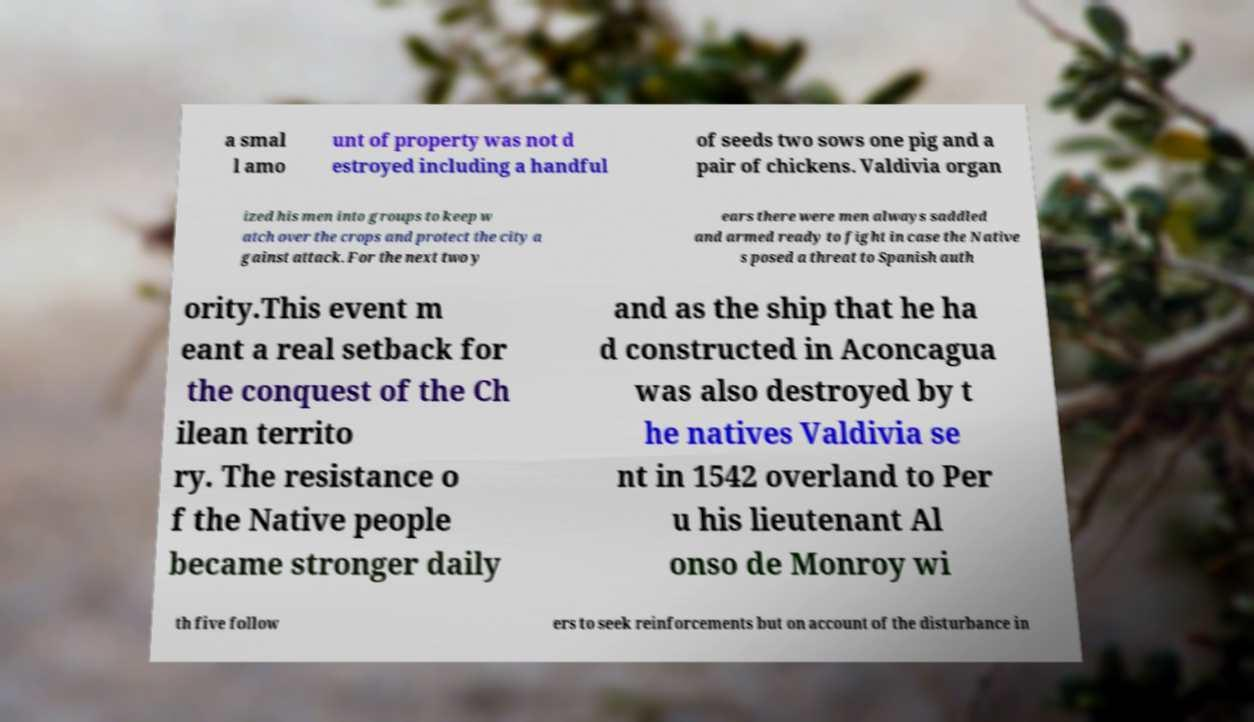I need the written content from this picture converted into text. Can you do that? a smal l amo unt of property was not d estroyed including a handful of seeds two sows one pig and a pair of chickens. Valdivia organ ized his men into groups to keep w atch over the crops and protect the city a gainst attack. For the next two y ears there were men always saddled and armed ready to fight in case the Native s posed a threat to Spanish auth ority.This event m eant a real setback for the conquest of the Ch ilean territo ry. The resistance o f the Native people became stronger daily and as the ship that he ha d constructed in Aconcagua was also destroyed by t he natives Valdivia se nt in 1542 overland to Per u his lieutenant Al onso de Monroy wi th five follow ers to seek reinforcements but on account of the disturbance in 